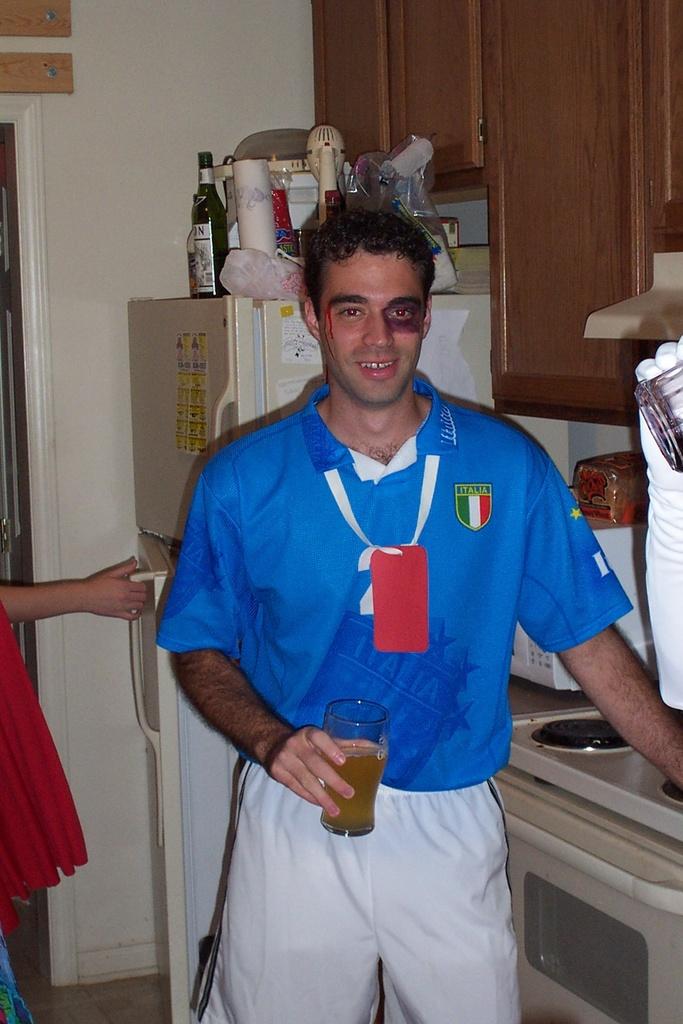What country is he representing?
Give a very brief answer. Italia. 